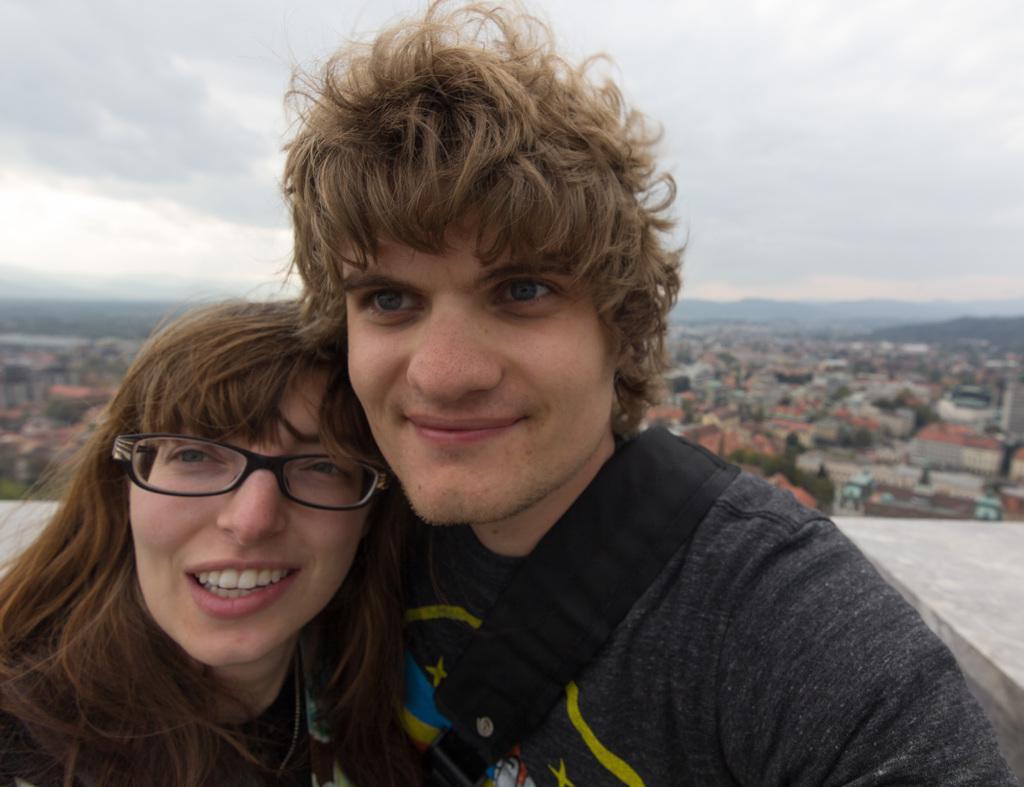Describe this image in one or two sentences. In this image, we can see a lady and a man standing and smiling. In the background, there are buildings and trees and we can see a wall. At the top, there is sky. 